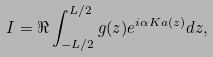Convert formula to latex. <formula><loc_0><loc_0><loc_500><loc_500>I = \Re \int _ { - L / 2 } ^ { L / 2 } g ( z ) e ^ { i \alpha K a ( z ) } d z ,</formula> 